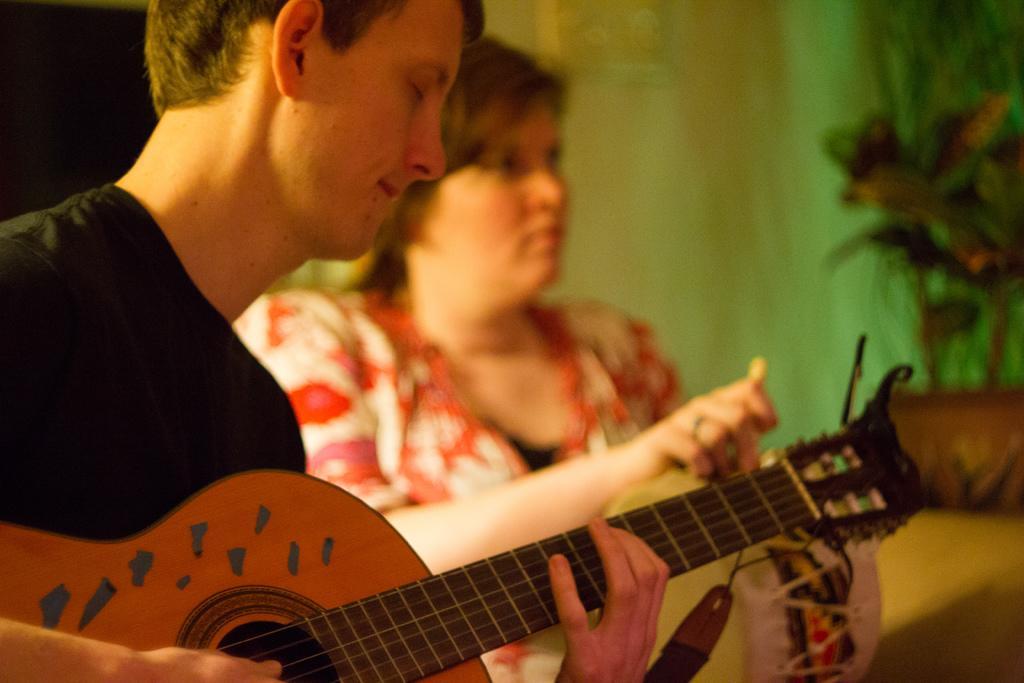Could you give a brief overview of what you see in this image? In this image there are two persons. The man is playing a guitar. 